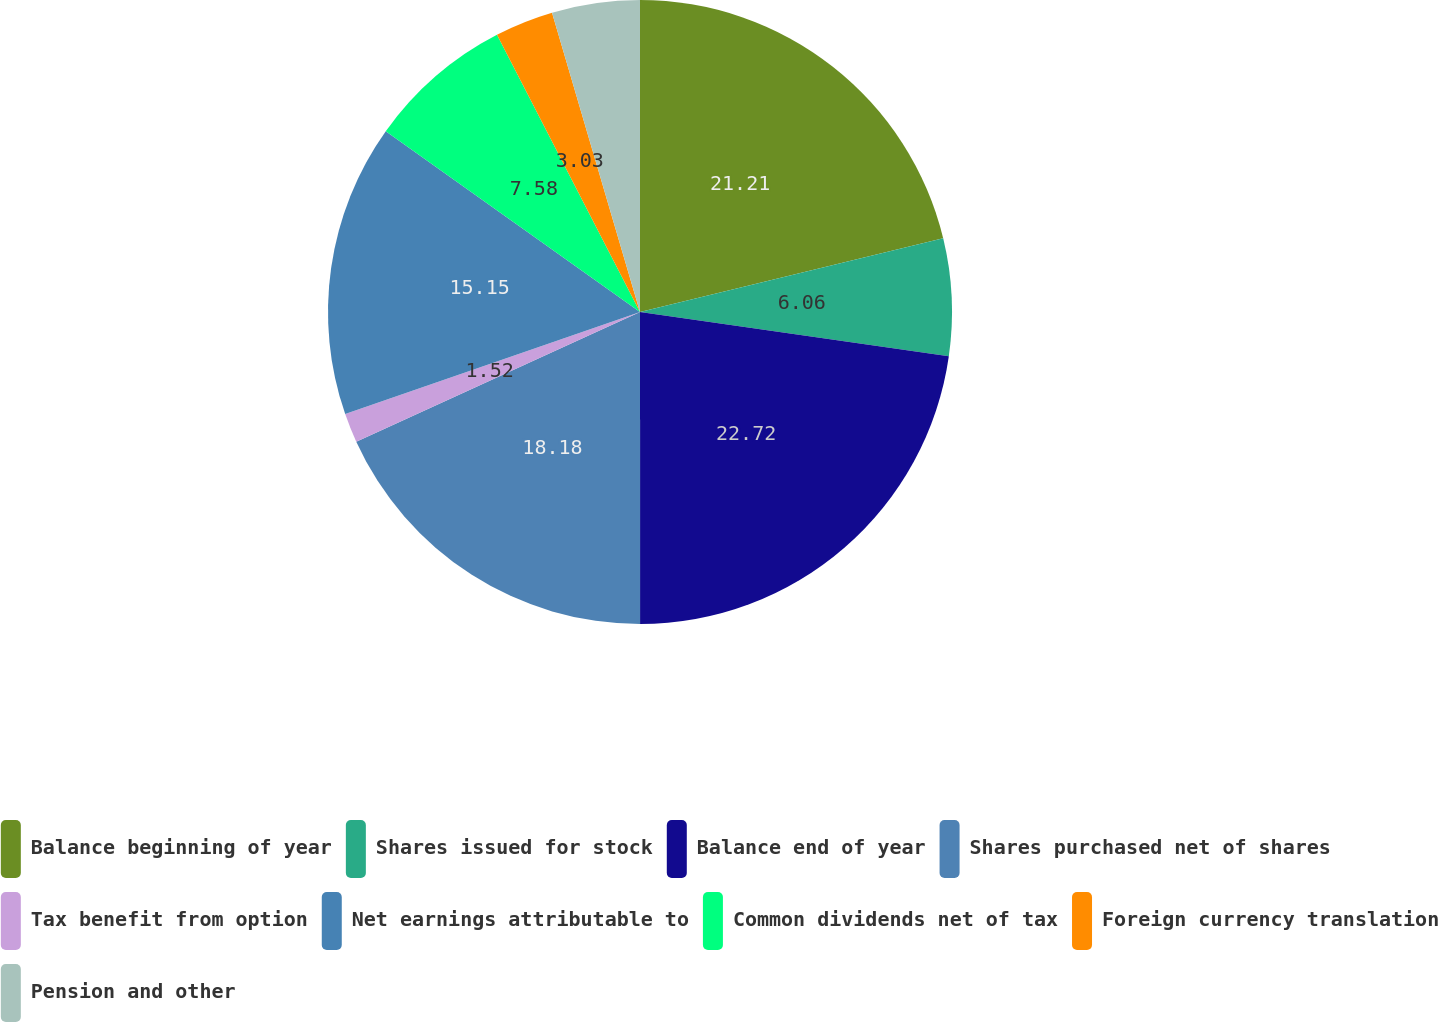<chart> <loc_0><loc_0><loc_500><loc_500><pie_chart><fcel>Balance beginning of year<fcel>Shares issued for stock<fcel>Balance end of year<fcel>Shares purchased net of shares<fcel>Tax benefit from option<fcel>Net earnings attributable to<fcel>Common dividends net of tax<fcel>Foreign currency translation<fcel>Pension and other<nl><fcel>21.21%<fcel>6.06%<fcel>22.73%<fcel>18.18%<fcel>1.52%<fcel>15.15%<fcel>7.58%<fcel>3.03%<fcel>4.55%<nl></chart> 